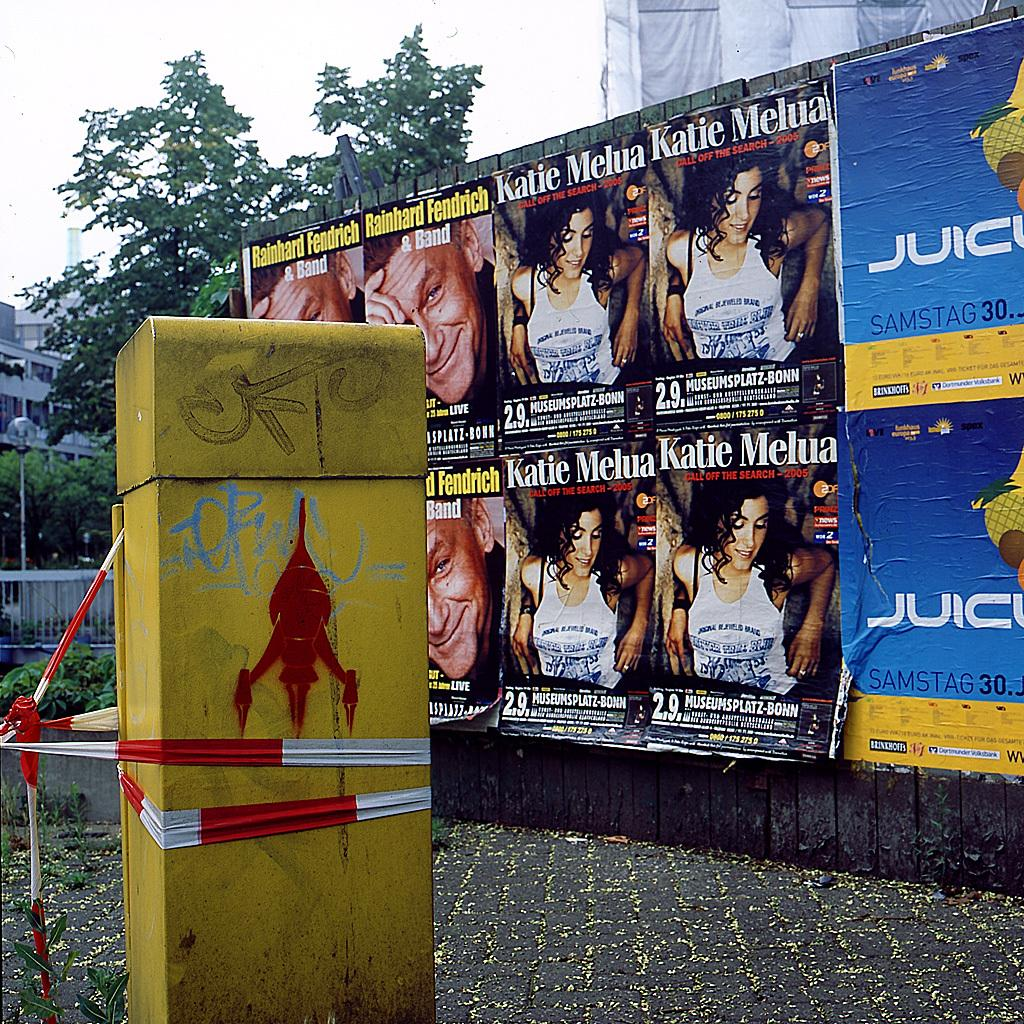<image>
Write a terse but informative summary of the picture. A gratified pillar that has been wrapped with police tap and a wall in the background that has some posters on it, some of which are for Katie Melua. 